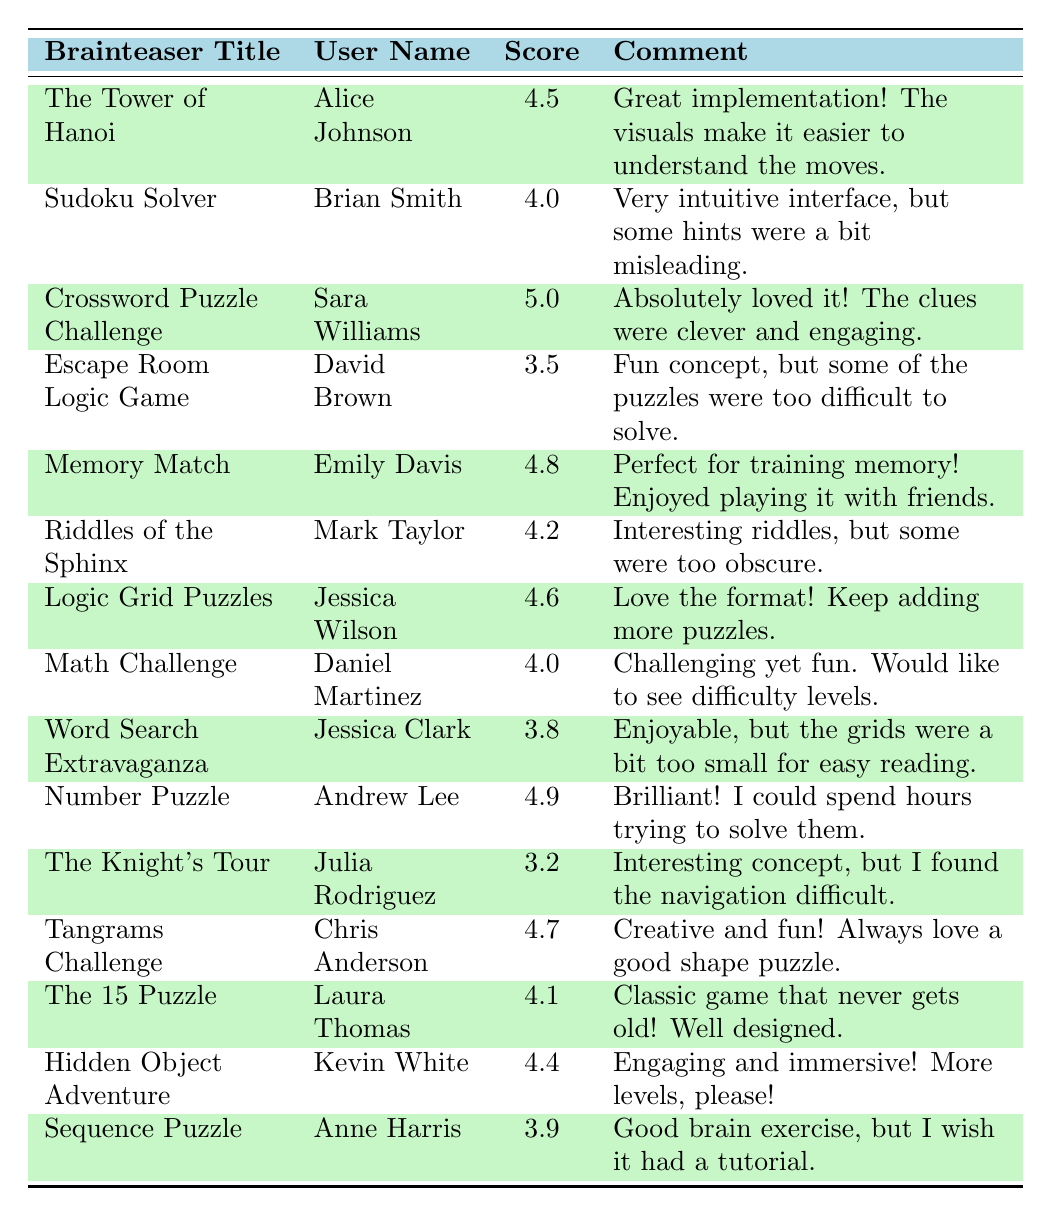What is the highest feedback score recorded in the table? The highest feedback score in the table is found by reviewing all the scores listed. The maximum score is 5.0, which comes from the comment for "Crossword Puzzle Challenge."
Answer: 5.0 Who is the user that gave a feedback score of 3.2? To find the user with a score of 3.2, we can look through the scores. The entry with a score of 3.2 corresponds to "The Knight's Tour," given by Julia Rodriguez.
Answer: Julia Rodriguez Calculate the average feedback score for all brainteasers. To calculate the average score, add all the feedback scores: (4.5 + 4.0 + 5.0 + 3.5 + 4.8 + 4.2 + 4.6 + 4.0 + 3.8 + 4.9 + 3.2 + 4.7 + 4.1 + 4.4 + 3.9) = 4.3. There are 15 scores, so the average is 4.3/15 = 4.4.
Answer: 4.4 Is there a user who gave a feedback score of 4.9? We check the user feedback scores to find any score listed as 4.9. The score of 4.9 appears for the "Number Puzzle," given by Andrew Lee, thus confirming the fact.
Answer: Yes Which brainteaser received the lowest score, and what was that score? To find the lowest score, we look through all the feedback scores and find that "The Knight's Tour" received the lowest score of 3.2.
Answer: The Knight's Tour, 3.2 How many users rated the "Memory Match" brainteaser? There is only one entry for "Memory Match" in the table, which means only one user rated it. So, there is just one count for this brainteaser.
Answer: 1 What is the difference between the highest and lowest feedback scores in the table? The highest score is 5.0 (from "Crossword Puzzle Challenge") and the lowest score is 3.2 (from "The Knight's Tour"). The difference is 5.0 - 3.2 = 1.8.
Answer: 1.8 Did any user leave a comment mentioning the word "puzzle"? By scanning through the comments, we find several instances of the word "puzzle" in comments for "The Tower of Hanoi," "Escape Room Logic Game," "Tangrams Challenge," and others. Hence, we can confirm there are comments with the word "puzzle."
Answer: Yes Which user provided feedback for "Sudoku Solver," and what was their score? To identify the user for "Sudoku Solver," we look for that title in the table, where it is noted that Brian Smith provided a score of 4.0.
Answer: Brian Smith, 4.0 Count how many brainteasers received scores above 4.5. Reviewing all scores, we find the following above 4.5: "The Tower of Hanoi" (4.5), "Crossword Puzzle Challenge" (5.0), "Memory Match" (4.8), "Logic Grid Puzzles" (4.6), "Number Puzzle" (4.9), and "Tangrams Challenge" (4.7). There are 6 scores above 4.5.
Answer: 6 